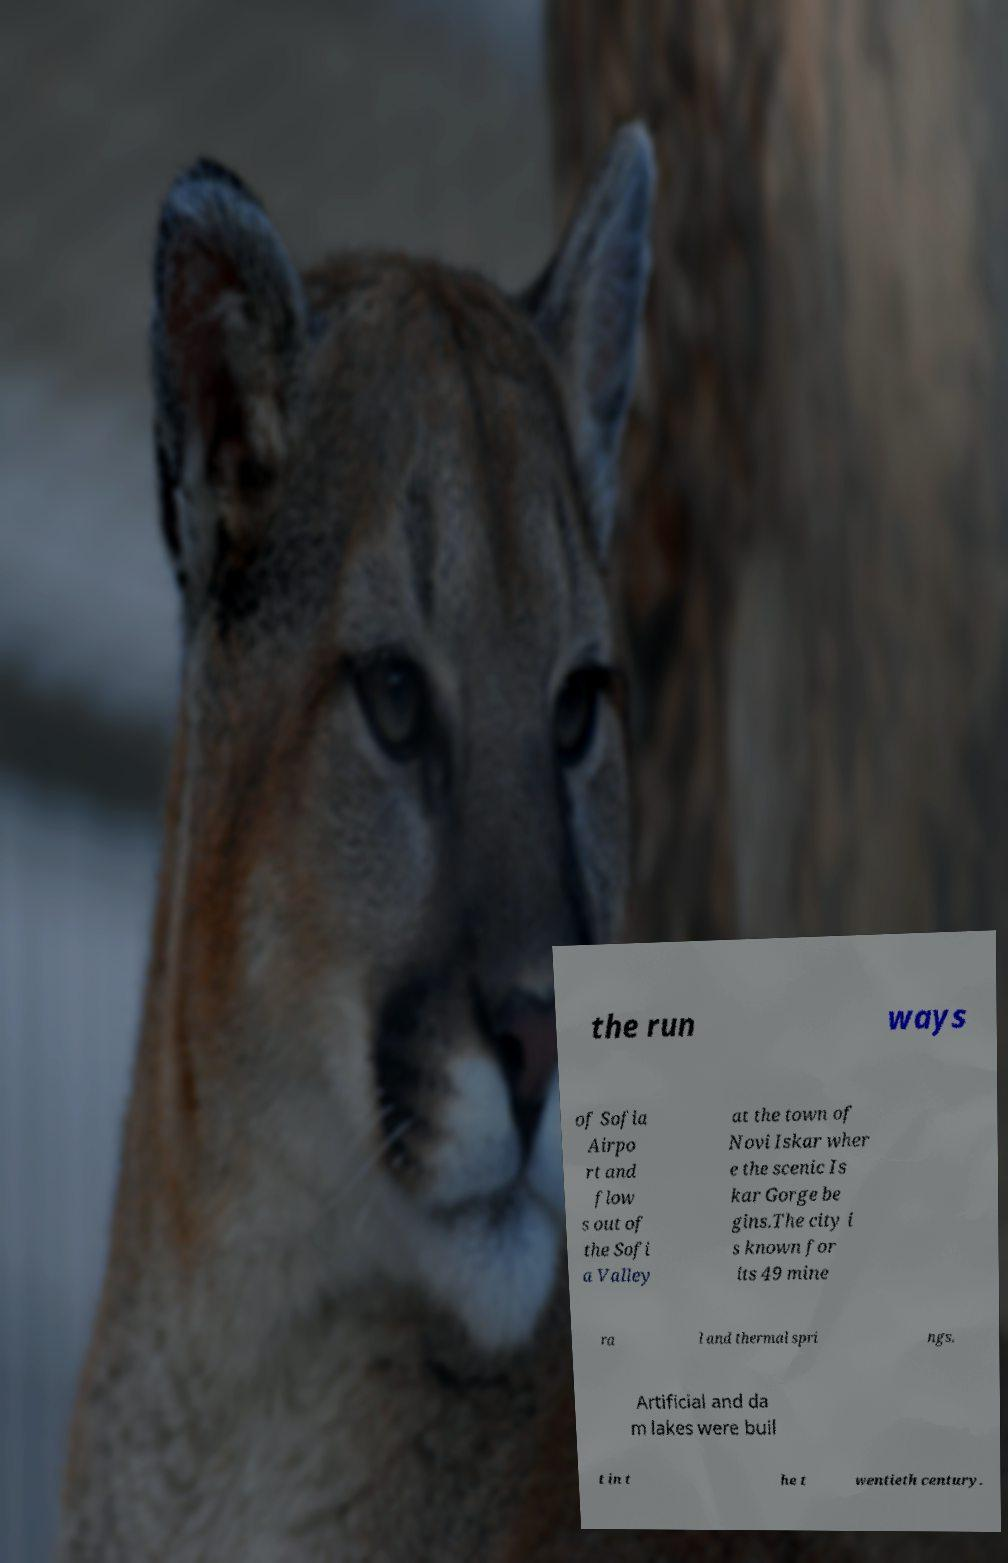Can you accurately transcribe the text from the provided image for me? the run ways of Sofia Airpo rt and flow s out of the Sofi a Valley at the town of Novi Iskar wher e the scenic Is kar Gorge be gins.The city i s known for its 49 mine ra l and thermal spri ngs. Artificial and da m lakes were buil t in t he t wentieth century. 